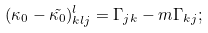Convert formula to latex. <formula><loc_0><loc_0><loc_500><loc_500>( \kappa _ { 0 } - \tilde { \kappa _ { 0 } } ) _ { k l j } ^ { l } = \Gamma _ { j k } - m \Gamma _ { k j } ;</formula> 